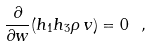Convert formula to latex. <formula><loc_0><loc_0><loc_500><loc_500>\frac { \partial } { \partial w } ( h _ { 1 } h _ { 3 } \rho \, v ) = 0 \ ,</formula> 